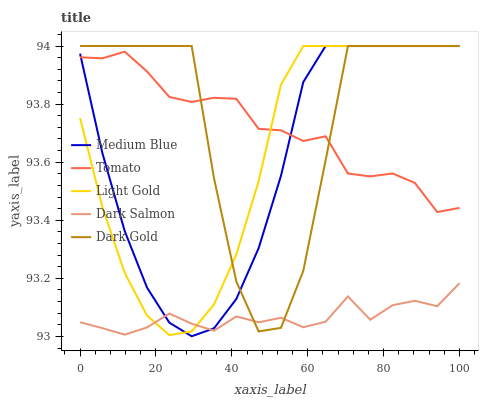Does Dark Salmon have the minimum area under the curve?
Answer yes or no. Yes. Does Dark Gold have the maximum area under the curve?
Answer yes or no. Yes. Does Light Gold have the minimum area under the curve?
Answer yes or no. No. Does Light Gold have the maximum area under the curve?
Answer yes or no. No. Is Light Gold the smoothest?
Answer yes or no. Yes. Is Dark Gold the roughest?
Answer yes or no. Yes. Is Medium Blue the smoothest?
Answer yes or no. No. Is Medium Blue the roughest?
Answer yes or no. No. Does Medium Blue have the lowest value?
Answer yes or no. Yes. Does Light Gold have the lowest value?
Answer yes or no. No. Does Dark Gold have the highest value?
Answer yes or no. Yes. Does Dark Salmon have the highest value?
Answer yes or no. No. Is Dark Salmon less than Tomato?
Answer yes or no. Yes. Is Tomato greater than Dark Salmon?
Answer yes or no. Yes. Does Tomato intersect Medium Blue?
Answer yes or no. Yes. Is Tomato less than Medium Blue?
Answer yes or no. No. Is Tomato greater than Medium Blue?
Answer yes or no. No. Does Dark Salmon intersect Tomato?
Answer yes or no. No. 